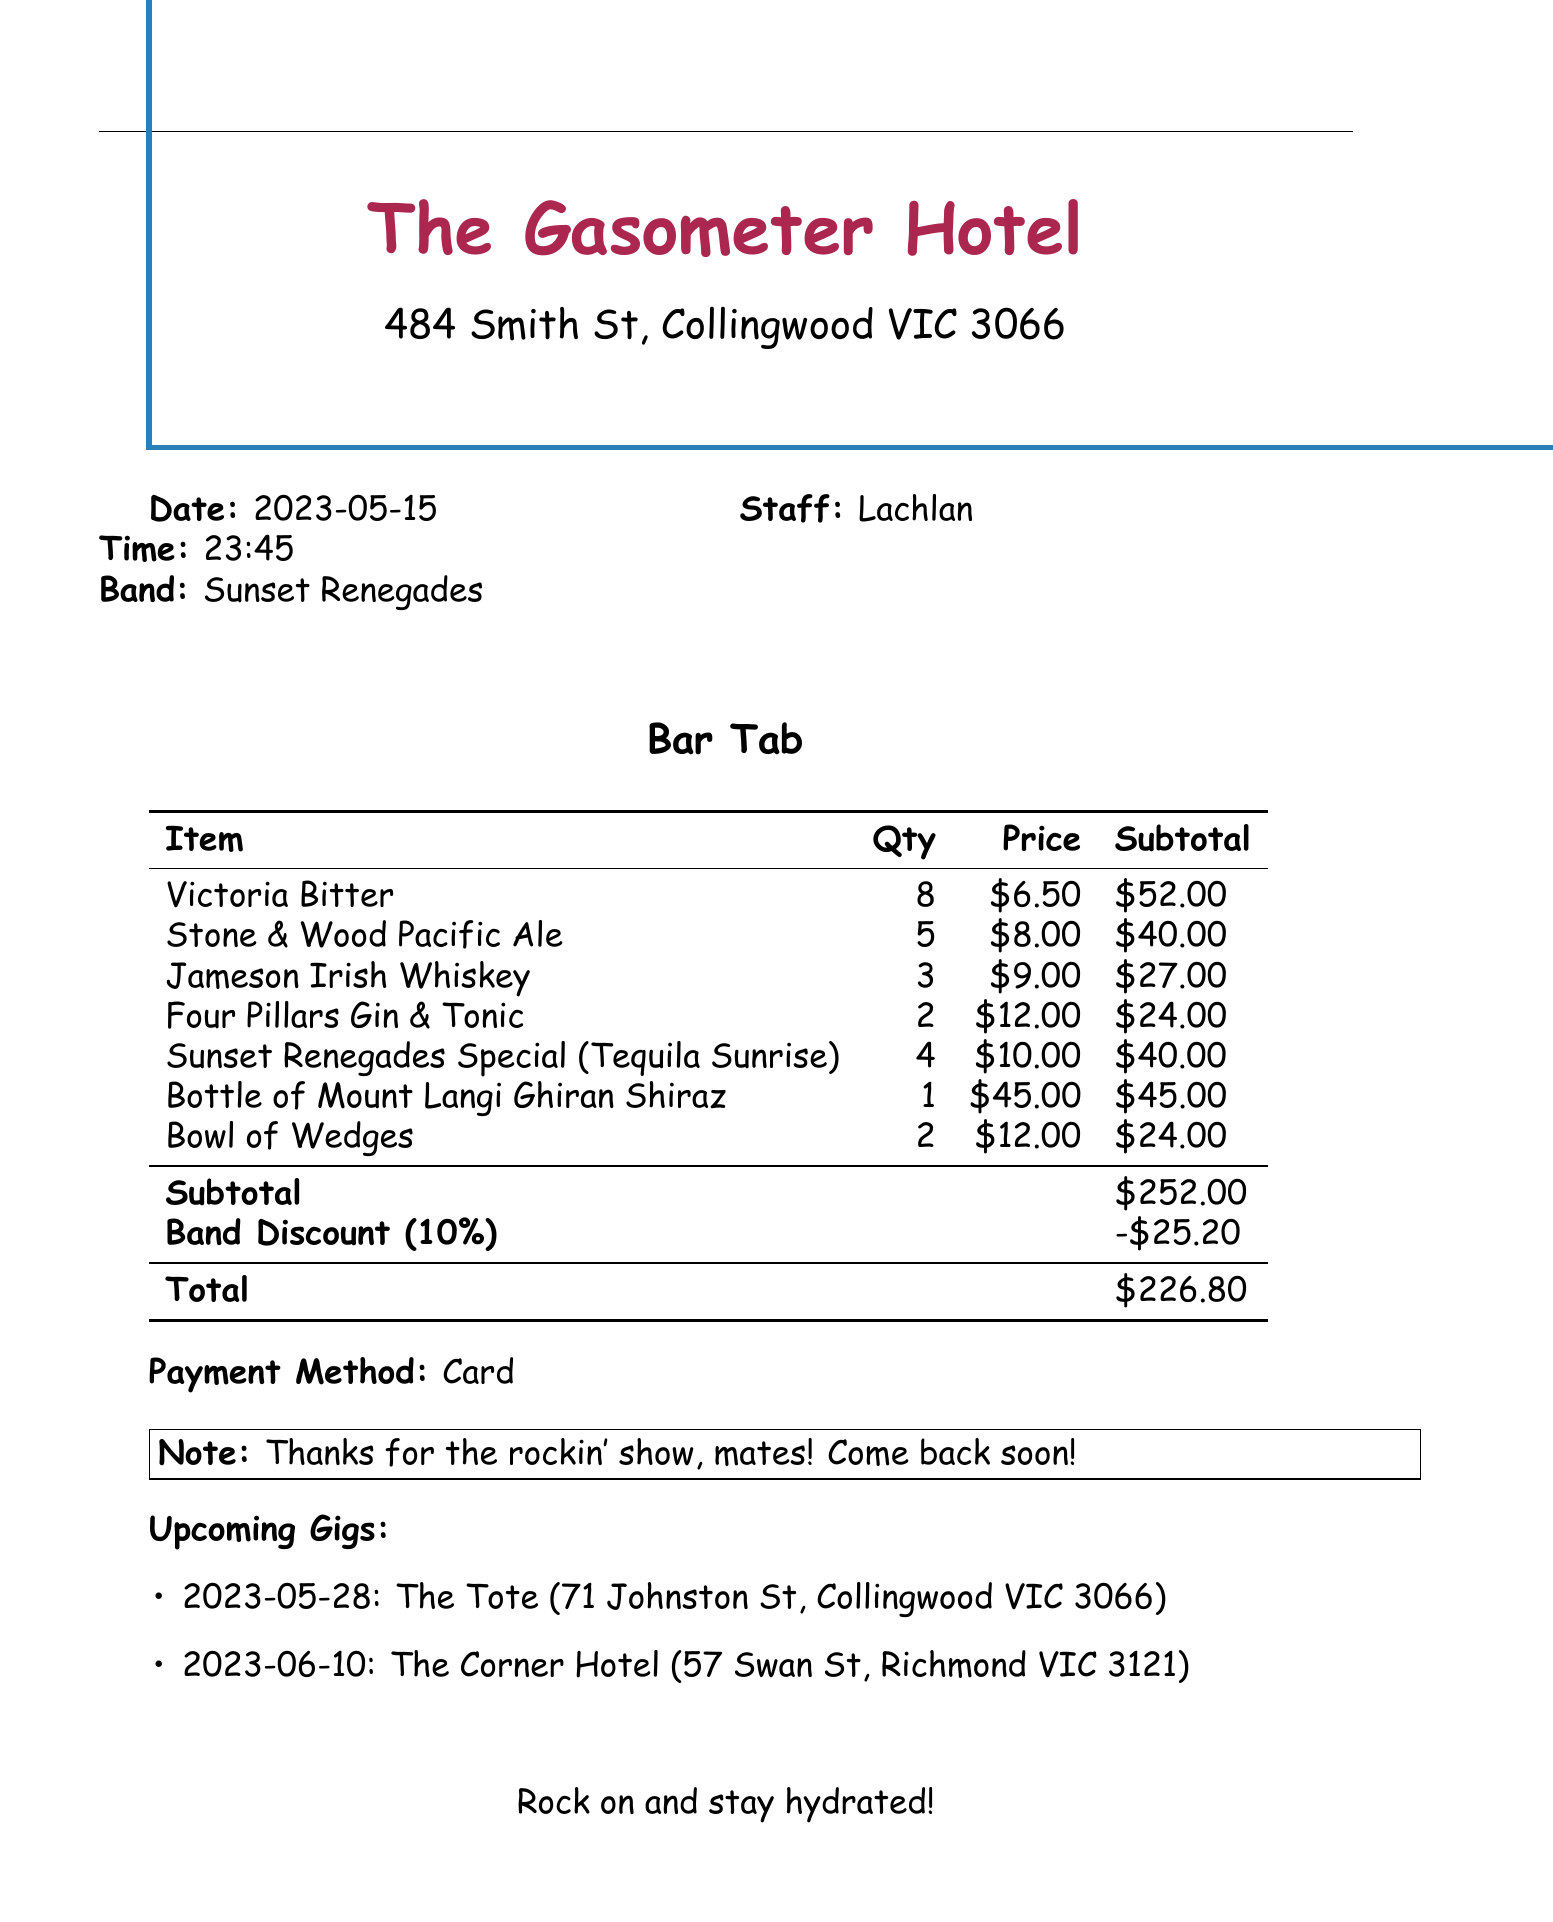What is the venue name? The venue name is listed at the top of the document.
Answer: The Gasometer Hotel What is the band name? The band name is mentioned in the document under the band section.
Answer: Sunset Renegades What was the total amount of the bar tab? The total amount is shown at the bottom of the bar tab section.
Answer: 226.80 How many Victoria Bitters were ordered? The quantity for Victoria Bitter is detailed in the items table.
Answer: 8 What discount was applied to the band? The band discount is specified in the subtotal section.
Answer: 25.20 What time did the event start? The time of the event is clearly indicated in the document.
Answer: 23:45 What type of drink is listed as the band's special? The band's special drink is described in the items section.
Answer: Tequila Sunrise How many upcoming gigs are mentioned? The document lists the upcoming gigs in a specific section.
Answer: 2 Who was the staff member serving? The name of the staff member is noted in the document.
Answer: Lachlan 